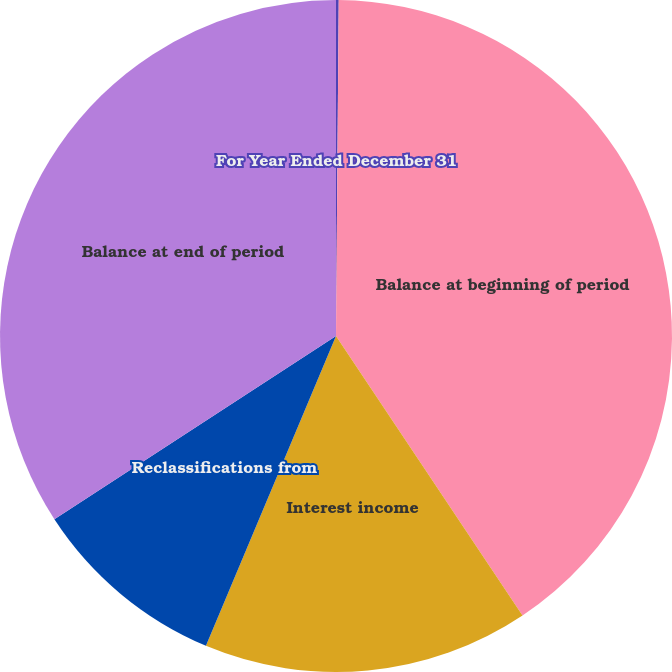Convert chart to OTSL. <chart><loc_0><loc_0><loc_500><loc_500><pie_chart><fcel>For Year Ended December 31<fcel>Balance at beginning of period<fcel>Interest income<fcel>Reclassifications from<fcel>Balance at end of period<nl><fcel>0.13%<fcel>40.5%<fcel>15.69%<fcel>9.49%<fcel>34.18%<nl></chart> 